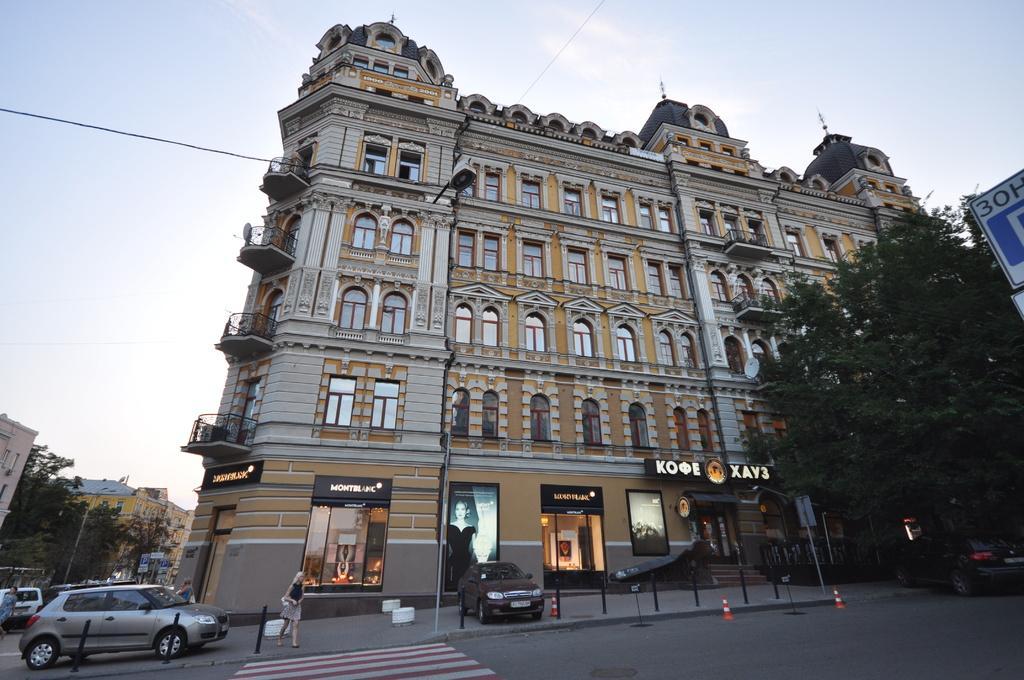How would you summarize this image in a sentence or two? In this picture there is a building in the center of the image and there are other buildings on the left side of the image and there are trees on the right and left side of the image, there are shops and cars at the bottom side of the image and there is a sign board on the right side of the image. 